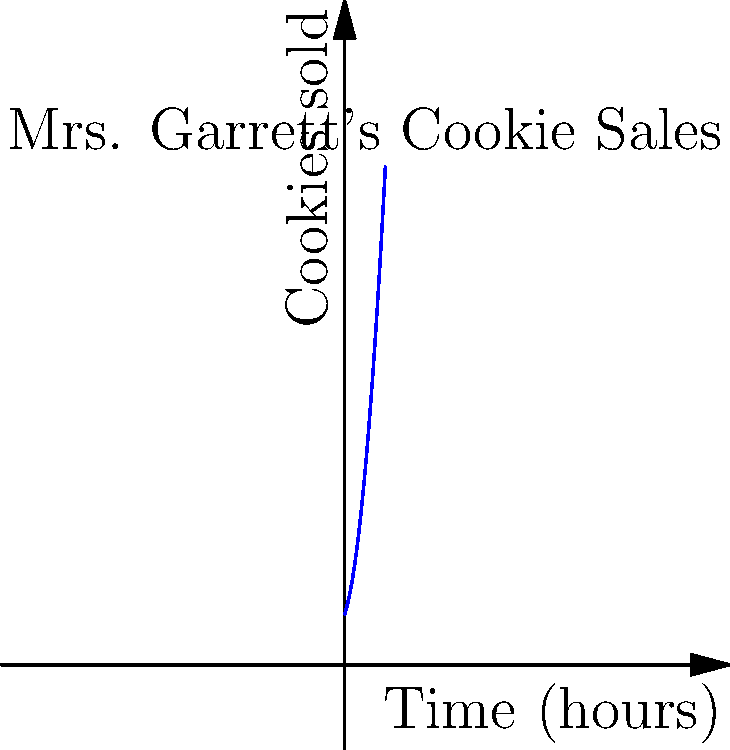Mrs. Garrett's cookie sales over time can be modeled by the function $f(t) = 2t^2 + 3t + 5$, where $t$ is the time in hours and $f(t)$ is the number of cookies sold. Calculate the total number of cookies sold during the first 4 hours. (Hint: This represents the area under the curve from $t=0$ to $t=4$.) To find the total number of cookies sold during the first 4 hours, we need to calculate the definite integral of the function $f(t) = 2t^2 + 3t + 5$ from $t=0$ to $t=4$. Let's approach this step-by-step:

1) The definite integral is given by:
   $$\int_0^4 (2t^2 + 3t + 5) dt$$

2) Integrate each term separately:
   $$\left[\frac{2t^3}{3} + \frac{3t^2}{2} + 5t\right]_0^4$$

3) Evaluate the integral at the upper and lower bounds:
   $$\left(\frac{2(4^3)}{3} + \frac{3(4^2)}{2} + 5(4)\right) - \left(\frac{2(0^3)}{3} + \frac{3(0^2)}{2} + 5(0)\right)$$

4) Simplify:
   $$\left(\frac{128}{3} + 24 + 20\right) - (0)$$
   $$= \frac{128}{3} + 44$$
   $$= \frac{128 + 132}{3}$$
   $$= \frac{260}{3}$$
   $$\approx 86.67$$

5) Since we're dealing with cookies, we round down to the nearest whole number.

Therefore, Mrs. Garrett sold approximately 86 cookies during the first 4 hours.
Answer: 86 cookies 